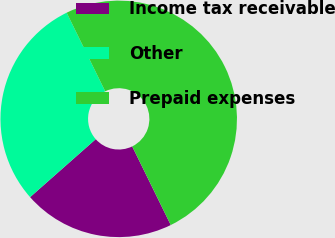<chart> <loc_0><loc_0><loc_500><loc_500><pie_chart><fcel>Income tax receivable<fcel>Other<fcel>Prepaid expenses<nl><fcel>20.74%<fcel>29.26%<fcel>50.0%<nl></chart> 